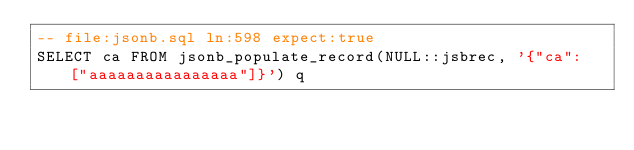<code> <loc_0><loc_0><loc_500><loc_500><_SQL_>-- file:jsonb.sql ln:598 expect:true
SELECT ca FROM jsonb_populate_record(NULL::jsbrec, '{"ca": ["aaaaaaaaaaaaaaaa"]}') q
</code> 